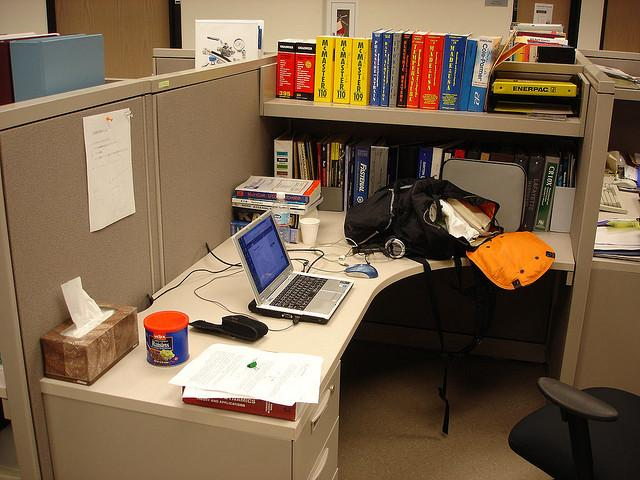What type of internet device is in use at this desk? Please explain your reasoning. desktop computer. The attached screen means it's not a desktop. the keyboard means it's not a tablet or a smartphone. 